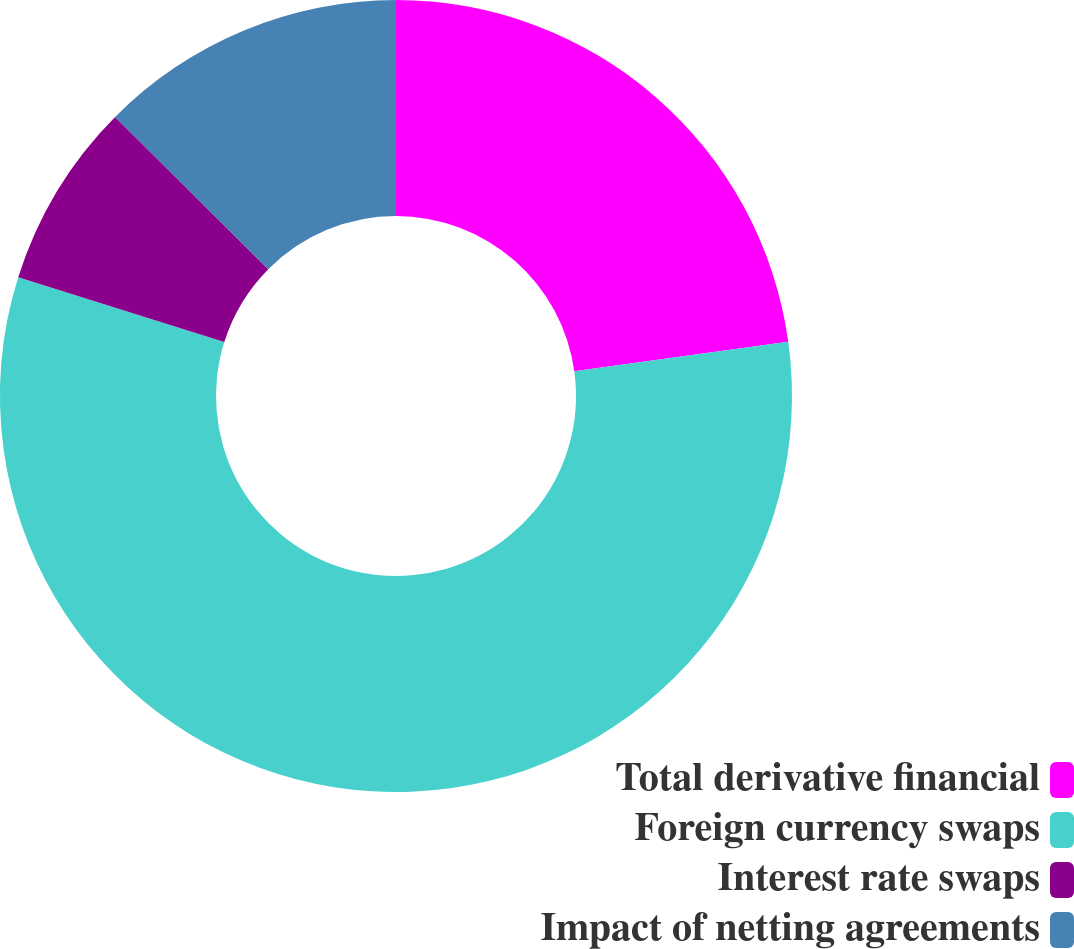Convert chart. <chart><loc_0><loc_0><loc_500><loc_500><pie_chart><fcel>Total derivative financial<fcel>Foreign currency swaps<fcel>Interest rate swaps<fcel>Impact of netting agreements<nl><fcel>22.81%<fcel>57.03%<fcel>7.6%<fcel>12.55%<nl></chart> 